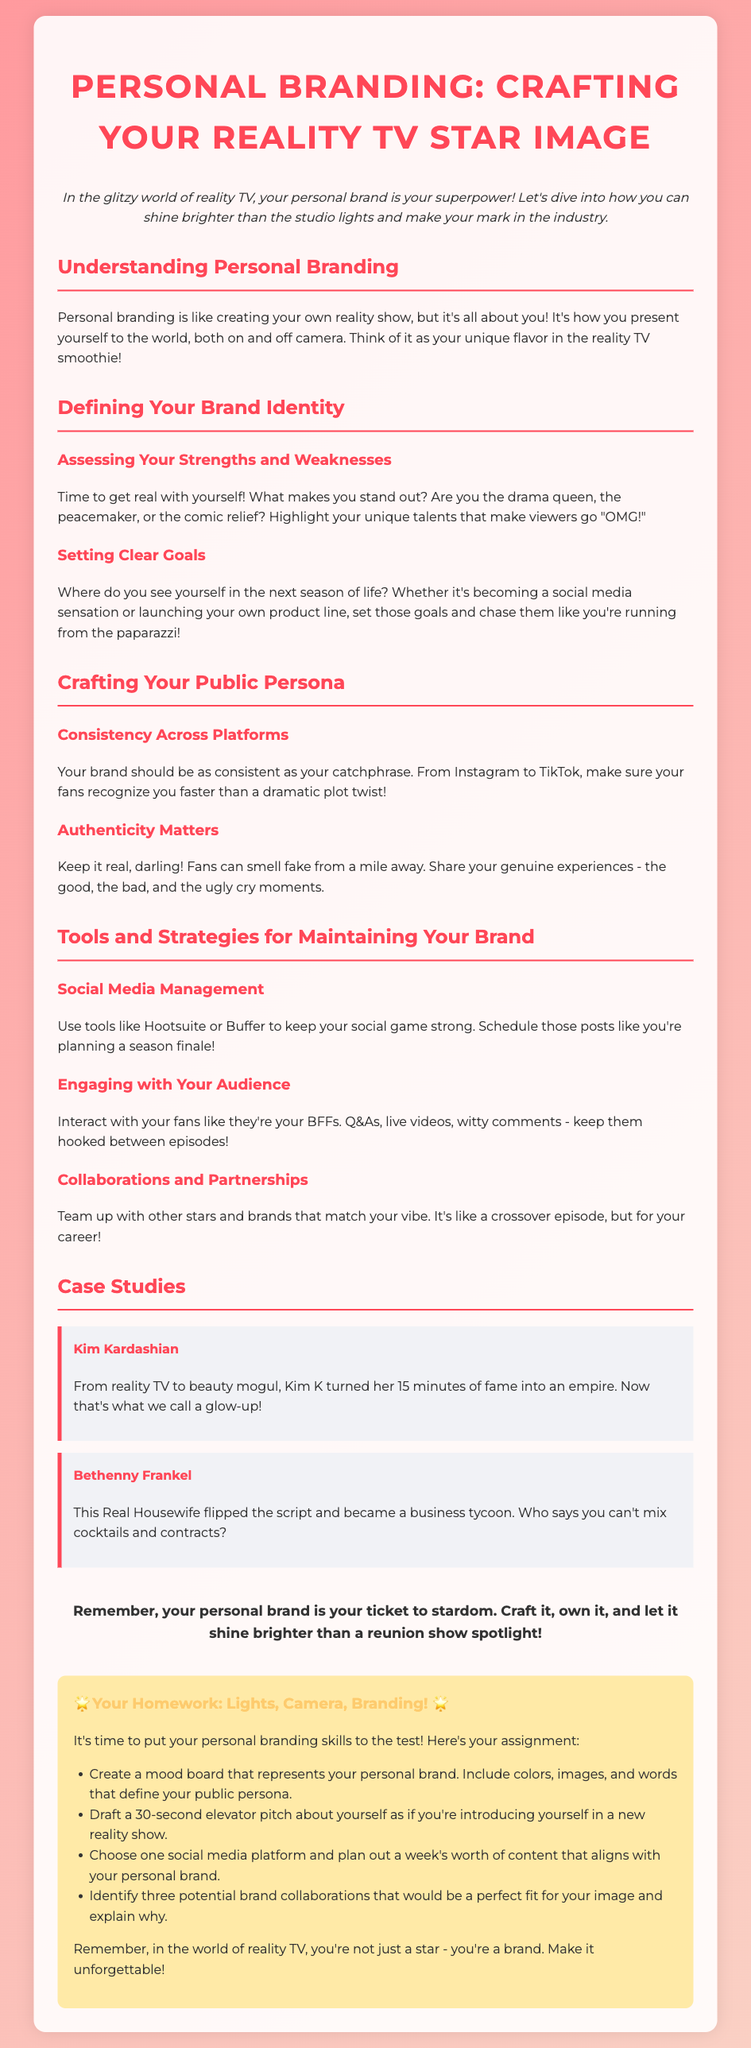What is the title of the homework? The title of the homework is mentioned at the top of the document.
Answer: Personal Branding: Crafting Your Reality TV Star Image What is the focus of personal branding? The focus of personal branding is explained in the introduction, emphasizing its importance in reality TV.
Answer: Crafting your unique flavor Who is used as a case study for a personal branding success? The document includes case studies of notable figures in reality TV.
Answer: Kim Kardashian What are the tools mentioned for social media management? The document lists specific tools that can help maintain a personal brand on social media.
Answer: Hootsuite or Buffer Name one element that should be consistent across platforms. The document notes the importance of consistency in branding across different media.
Answer: Your brand What is suggested for engaging with your audience? The document provides a strategy for maintaining connection with fans.
Answer: Interact like BFFs How many homework tasks are listed? The homework section of the document outlines specific tasks to be completed.
Answer: Four What should you create to represent your personal brand? The document instructs students to create something visually representative of their brand.
Answer: A mood board What should your elevator pitch introduction be for? The purpose of the elevator pitch is outlined in the homework tasks.
Answer: A new reality show 